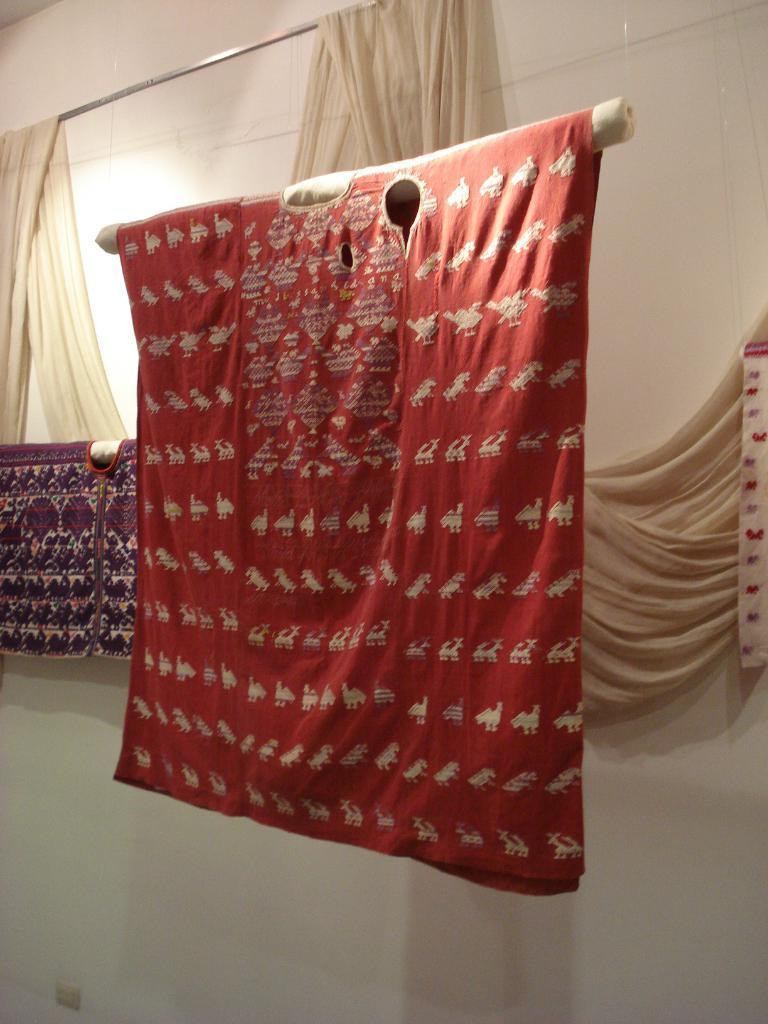Describe this image in one or two sentences. In the image in the center, we can see the hangers and curtains. In the background, there is a wall. 